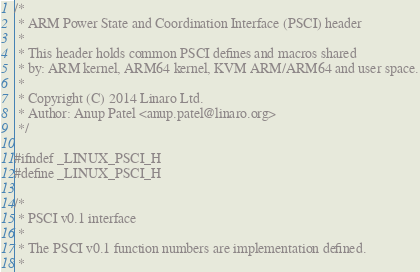Convert code to text. <code><loc_0><loc_0><loc_500><loc_500><_C_>/*
 * ARM Power State and Coordination Interface (PSCI) header
 *
 * This header holds common PSCI defines and macros shared
 * by: ARM kernel, ARM64 kernel, KVM ARM/ARM64 and user space.
 *
 * Copyright (C) 2014 Linaro Ltd.
 * Author: Anup Patel <anup.patel@linaro.org>
 */

#ifndef _LINUX_PSCI_H
#define _LINUX_PSCI_H

/*
 * PSCI v0.1 interface
 *
 * The PSCI v0.1 function numbers are implementation defined.
 *</code> 